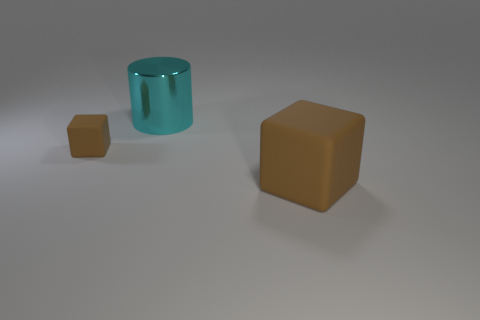Subtract all purple cylinders. Subtract all blue balls. How many cylinders are left? 1 Add 2 big brown blocks. How many objects exist? 5 Subtract all cylinders. How many objects are left? 2 Add 3 brown matte cubes. How many brown matte cubes are left? 5 Add 1 big purple metal spheres. How many big purple metal spheres exist? 1 Subtract 0 purple cylinders. How many objects are left? 3 Subtract all big cyan cylinders. Subtract all tiny brown things. How many objects are left? 1 